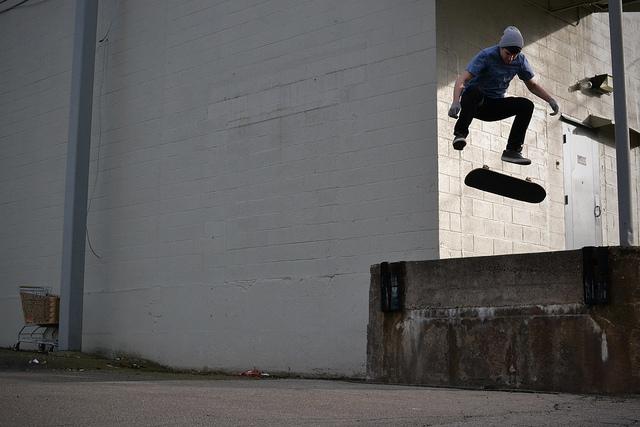What is present?
Write a very short answer. Skateboarder. Is this person in the air?
Give a very brief answer. Yes. What structure is he using to do tricks?
Be succinct. Ramp. What is this person doing?
Answer briefly. Skateboarding. Is it sunny?
Give a very brief answer. Yes. What item can be seen in the background?
Write a very short answer. Shopping cart. 